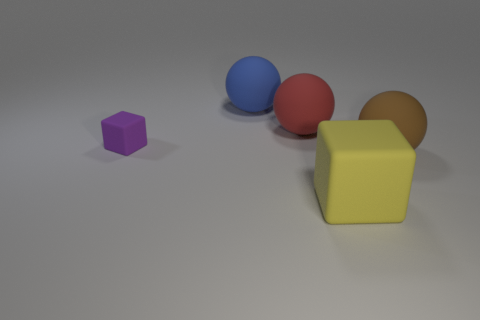Add 2 large brown rubber things. How many objects exist? 7 Subtract all cubes. How many objects are left? 3 Add 1 large blue things. How many large blue things exist? 2 Subtract 0 cyan balls. How many objects are left? 5 Subtract all purple shiny cylinders. Subtract all large objects. How many objects are left? 1 Add 5 large blue matte things. How many large blue matte things are left? 6 